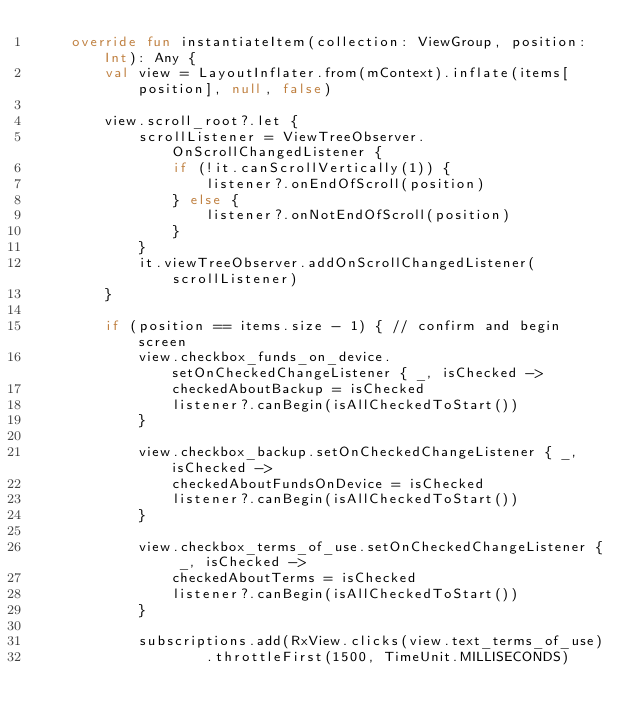Convert code to text. <code><loc_0><loc_0><loc_500><loc_500><_Kotlin_>    override fun instantiateItem(collection: ViewGroup, position: Int): Any {
        val view = LayoutInflater.from(mContext).inflate(items[position], null, false)

        view.scroll_root?.let {
            scrollListener = ViewTreeObserver.OnScrollChangedListener {
                if (!it.canScrollVertically(1)) {
                    listener?.onEndOfScroll(position)
                } else {
                    listener?.onNotEndOfScroll(position)
                }
            }
            it.viewTreeObserver.addOnScrollChangedListener(scrollListener)
        }

        if (position == items.size - 1) { // confirm and begin screen
            view.checkbox_funds_on_device.setOnCheckedChangeListener { _, isChecked ->
                checkedAboutBackup = isChecked
                listener?.canBegin(isAllCheckedToStart())
            }

            view.checkbox_backup.setOnCheckedChangeListener { _, isChecked ->
                checkedAboutFundsOnDevice = isChecked
                listener?.canBegin(isAllCheckedToStart())
            }

            view.checkbox_terms_of_use.setOnCheckedChangeListener { _, isChecked ->
                checkedAboutTerms = isChecked
                listener?.canBegin(isAllCheckedToStart())
            }

            subscriptions.add(RxView.clicks(view.text_terms_of_use)
                    .throttleFirst(1500, TimeUnit.MILLISECONDS)</code> 